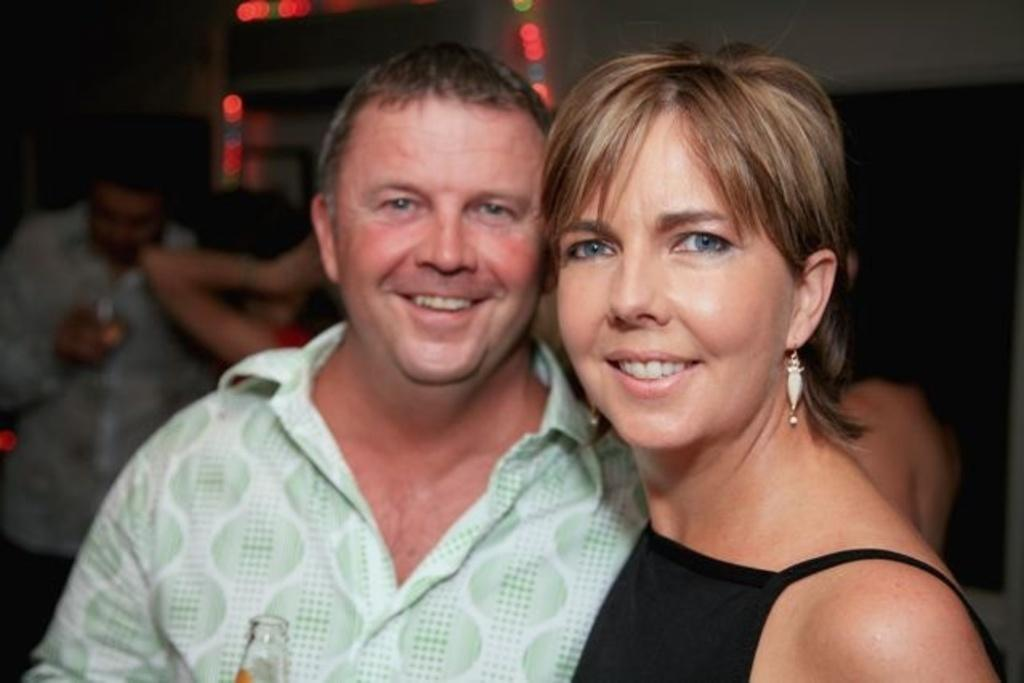Who is present in the image? There is a man and a woman present in the image. What is the man wearing? The man is wearing a green shirt. What is the man holding? The man is holding a bottle. What is the woman wearing? The woman is wearing black. Can you describe the people in the background of the image? There are people in the background of the image, but their clothing and actions are not specified. What type of star can be seen in the image? There is no star present in the image. What type of labor is the man performing in the image? The provided facts do not mention any labor or work being performed by the man in the image. 